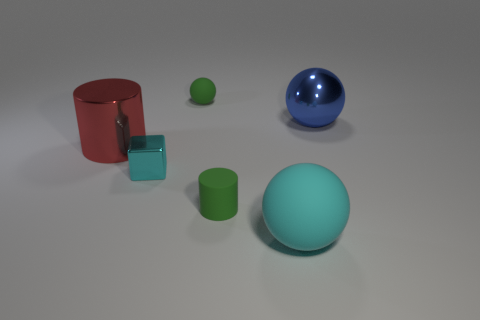Subtract all large spheres. How many spheres are left? 1 Add 2 big red metal cylinders. How many objects exist? 8 Subtract all purple spheres. Subtract all brown cylinders. How many spheres are left? 3 Subtract all cubes. How many objects are left? 5 Add 6 cylinders. How many cylinders are left? 8 Add 2 large yellow cylinders. How many large yellow cylinders exist? 2 Subtract 0 gray cubes. How many objects are left? 6 Subtract all purple metal cubes. Subtract all rubber cylinders. How many objects are left? 5 